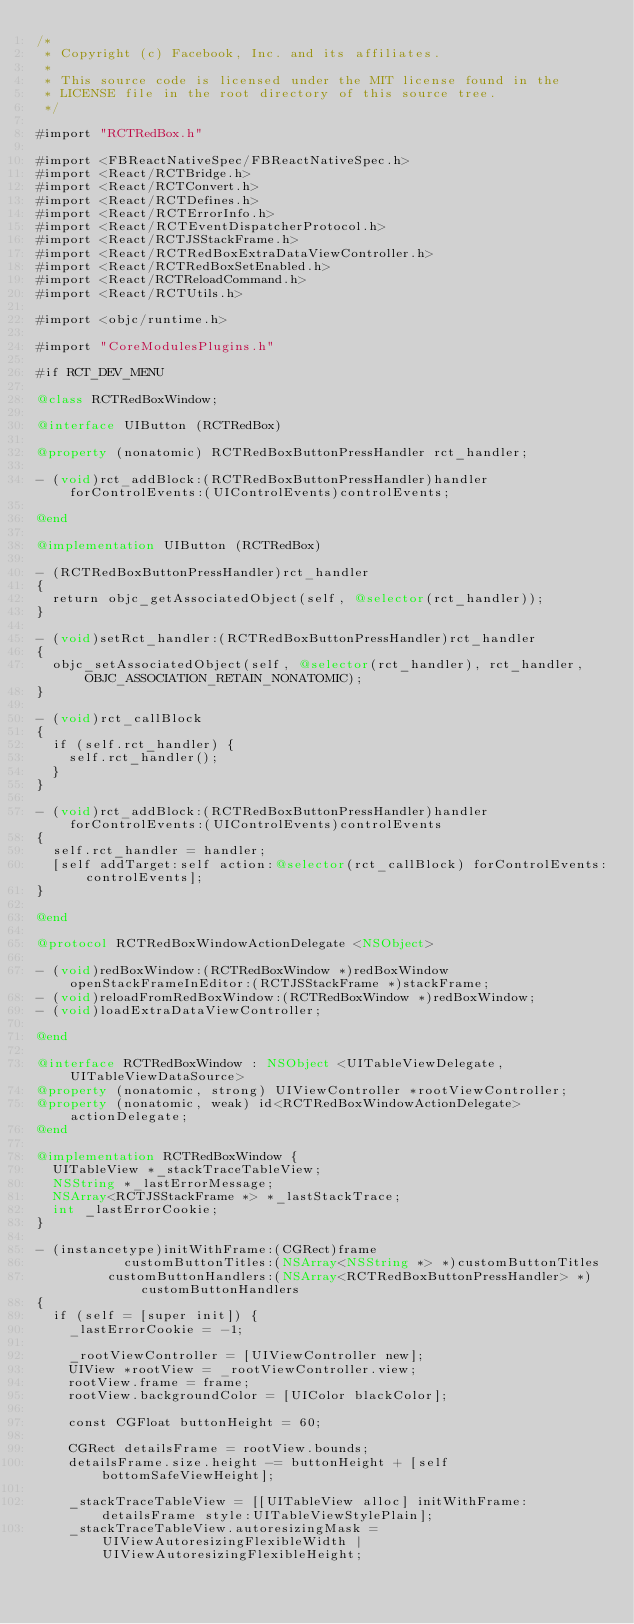Convert code to text. <code><loc_0><loc_0><loc_500><loc_500><_ObjectiveC_>/*
 * Copyright (c) Facebook, Inc. and its affiliates.
 *
 * This source code is licensed under the MIT license found in the
 * LICENSE file in the root directory of this source tree.
 */

#import "RCTRedBox.h"

#import <FBReactNativeSpec/FBReactNativeSpec.h>
#import <React/RCTBridge.h>
#import <React/RCTConvert.h>
#import <React/RCTDefines.h>
#import <React/RCTErrorInfo.h>
#import <React/RCTEventDispatcherProtocol.h>
#import <React/RCTJSStackFrame.h>
#import <React/RCTRedBoxExtraDataViewController.h>
#import <React/RCTRedBoxSetEnabled.h>
#import <React/RCTReloadCommand.h>
#import <React/RCTUtils.h>

#import <objc/runtime.h>

#import "CoreModulesPlugins.h"

#if RCT_DEV_MENU

@class RCTRedBoxWindow;

@interface UIButton (RCTRedBox)

@property (nonatomic) RCTRedBoxButtonPressHandler rct_handler;

- (void)rct_addBlock:(RCTRedBoxButtonPressHandler)handler forControlEvents:(UIControlEvents)controlEvents;

@end

@implementation UIButton (RCTRedBox)

- (RCTRedBoxButtonPressHandler)rct_handler
{
  return objc_getAssociatedObject(self, @selector(rct_handler));
}

- (void)setRct_handler:(RCTRedBoxButtonPressHandler)rct_handler
{
  objc_setAssociatedObject(self, @selector(rct_handler), rct_handler, OBJC_ASSOCIATION_RETAIN_NONATOMIC);
}

- (void)rct_callBlock
{
  if (self.rct_handler) {
    self.rct_handler();
  }
}

- (void)rct_addBlock:(RCTRedBoxButtonPressHandler)handler forControlEvents:(UIControlEvents)controlEvents
{
  self.rct_handler = handler;
  [self addTarget:self action:@selector(rct_callBlock) forControlEvents:controlEvents];
}

@end

@protocol RCTRedBoxWindowActionDelegate <NSObject>

- (void)redBoxWindow:(RCTRedBoxWindow *)redBoxWindow openStackFrameInEditor:(RCTJSStackFrame *)stackFrame;
- (void)reloadFromRedBoxWindow:(RCTRedBoxWindow *)redBoxWindow;
- (void)loadExtraDataViewController;

@end

@interface RCTRedBoxWindow : NSObject <UITableViewDelegate, UITableViewDataSource>
@property (nonatomic, strong) UIViewController *rootViewController;
@property (nonatomic, weak) id<RCTRedBoxWindowActionDelegate> actionDelegate;
@end

@implementation RCTRedBoxWindow {
  UITableView *_stackTraceTableView;
  NSString *_lastErrorMessage;
  NSArray<RCTJSStackFrame *> *_lastStackTrace;
  int _lastErrorCookie;
}

- (instancetype)initWithFrame:(CGRect)frame
           customButtonTitles:(NSArray<NSString *> *)customButtonTitles
         customButtonHandlers:(NSArray<RCTRedBoxButtonPressHandler> *)customButtonHandlers
{
  if (self = [super init]) {
    _lastErrorCookie = -1;

    _rootViewController = [UIViewController new];
    UIView *rootView = _rootViewController.view;
    rootView.frame = frame;
    rootView.backgroundColor = [UIColor blackColor];

    const CGFloat buttonHeight = 60;

    CGRect detailsFrame = rootView.bounds;
    detailsFrame.size.height -= buttonHeight + [self bottomSafeViewHeight];

    _stackTraceTableView = [[UITableView alloc] initWithFrame:detailsFrame style:UITableViewStylePlain];
    _stackTraceTableView.autoresizingMask = UIViewAutoresizingFlexibleWidth | UIViewAutoresizingFlexibleHeight;</code> 